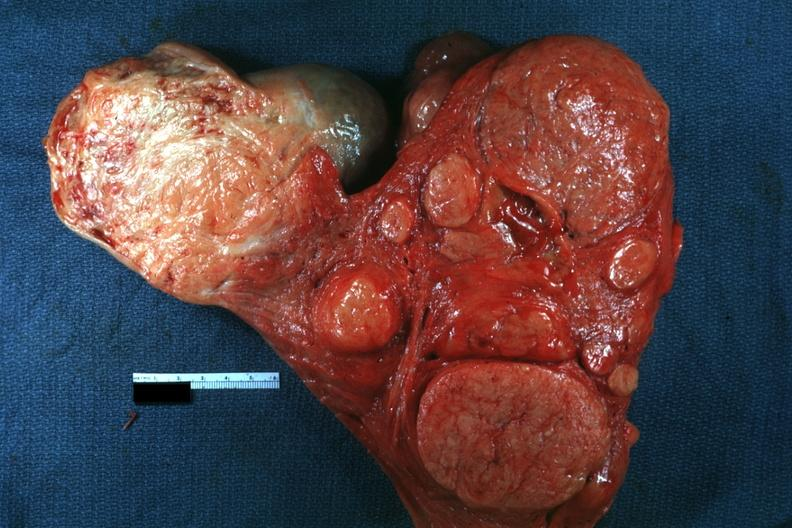does 70yof show multiple typical lesions good depiction?
Answer the question using a single word or phrase. No 